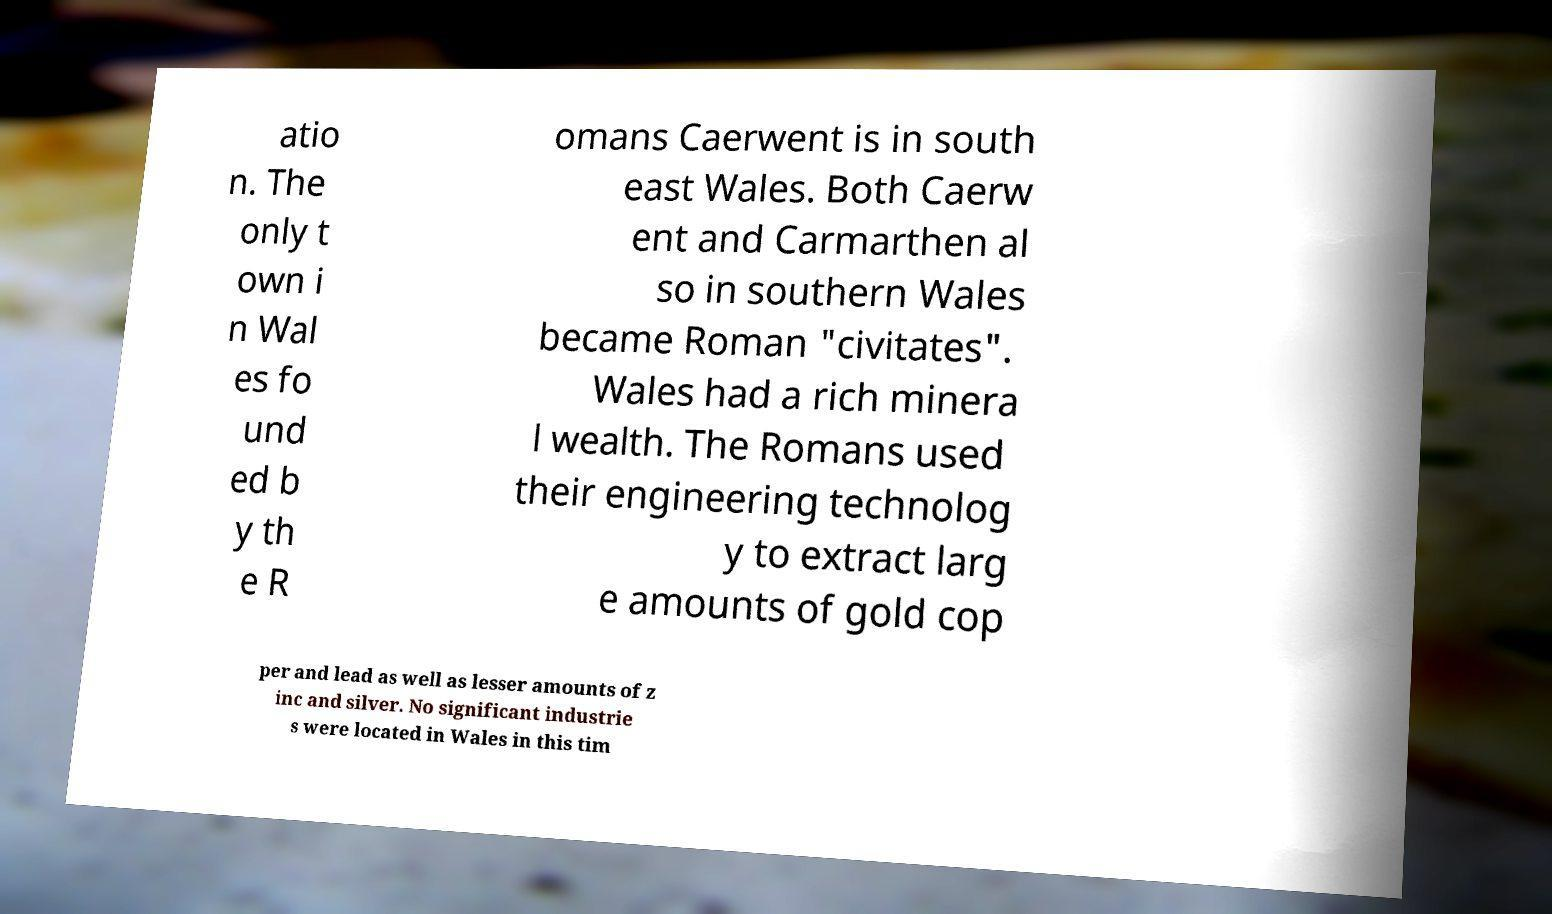Could you assist in decoding the text presented in this image and type it out clearly? atio n. The only t own i n Wal es fo und ed b y th e R omans Caerwent is in south east Wales. Both Caerw ent and Carmarthen al so in southern Wales became Roman "civitates". Wales had a rich minera l wealth. The Romans used their engineering technolog y to extract larg e amounts of gold cop per and lead as well as lesser amounts of z inc and silver. No significant industrie s were located in Wales in this tim 